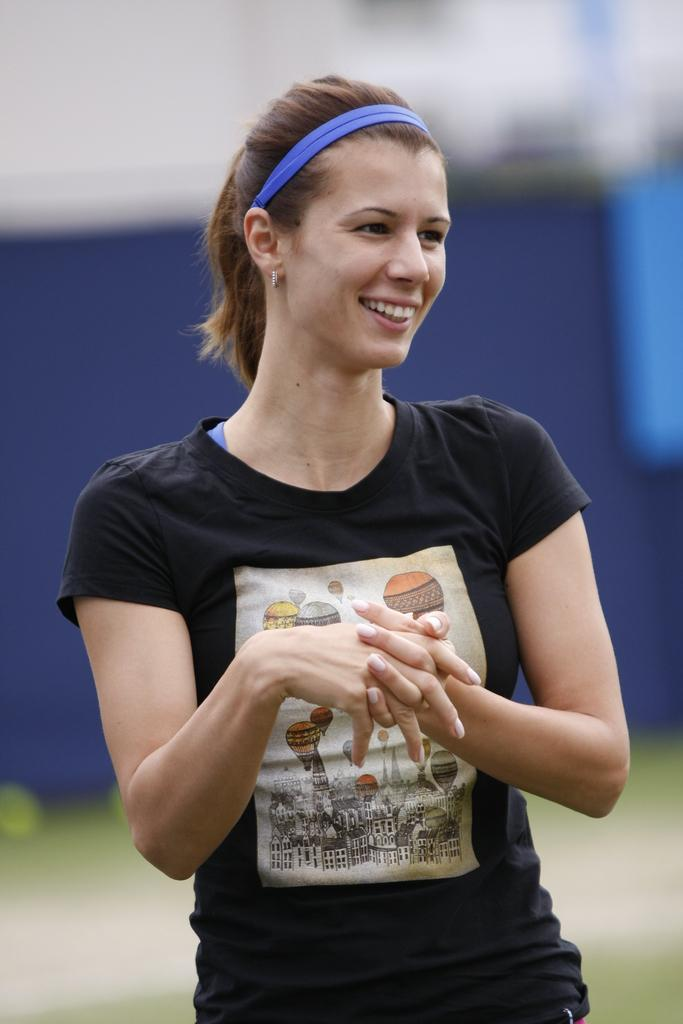Who is present in the image? There is a woman in the image. What is the woman doing in the image? The woman is standing and smiling. What is the woman wearing in the image? The woman is wearing a black t-shirt. Can you describe the background of the image? The background of the image is blurry. How many friends can be seen holding an ornament in the image? There are no friends or ornaments present in the image; it features a woman standing and smiling. 